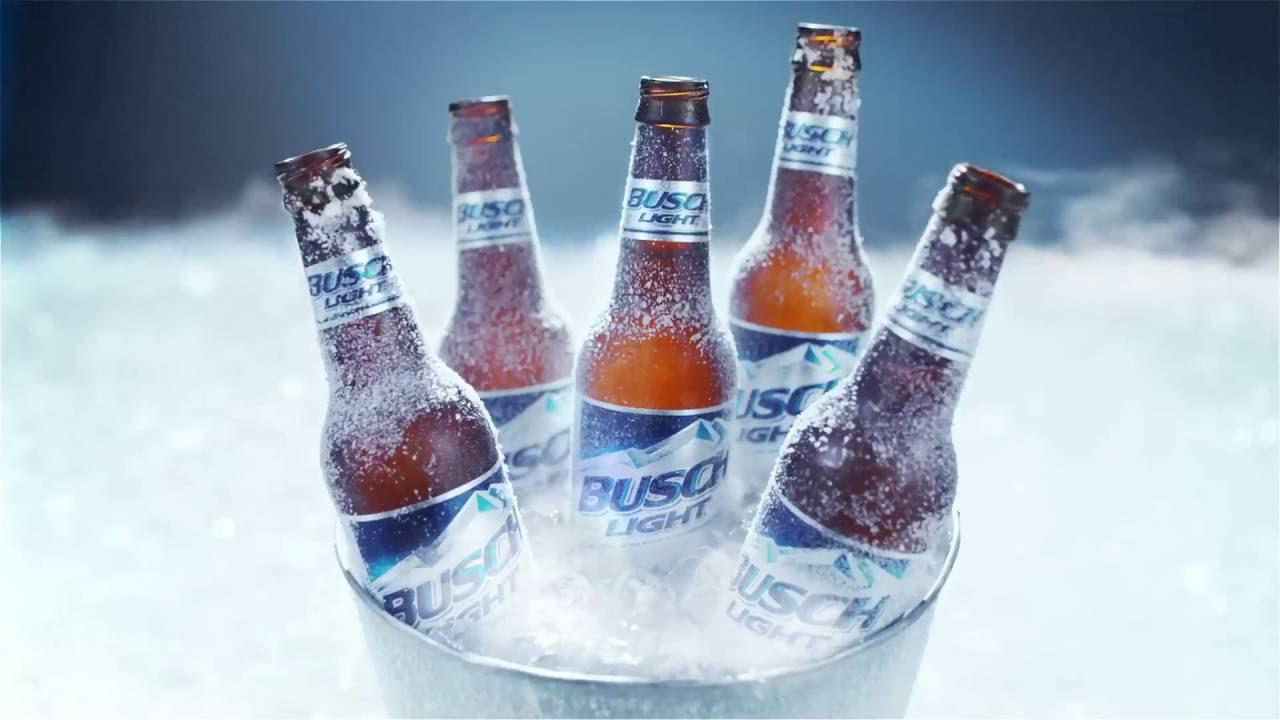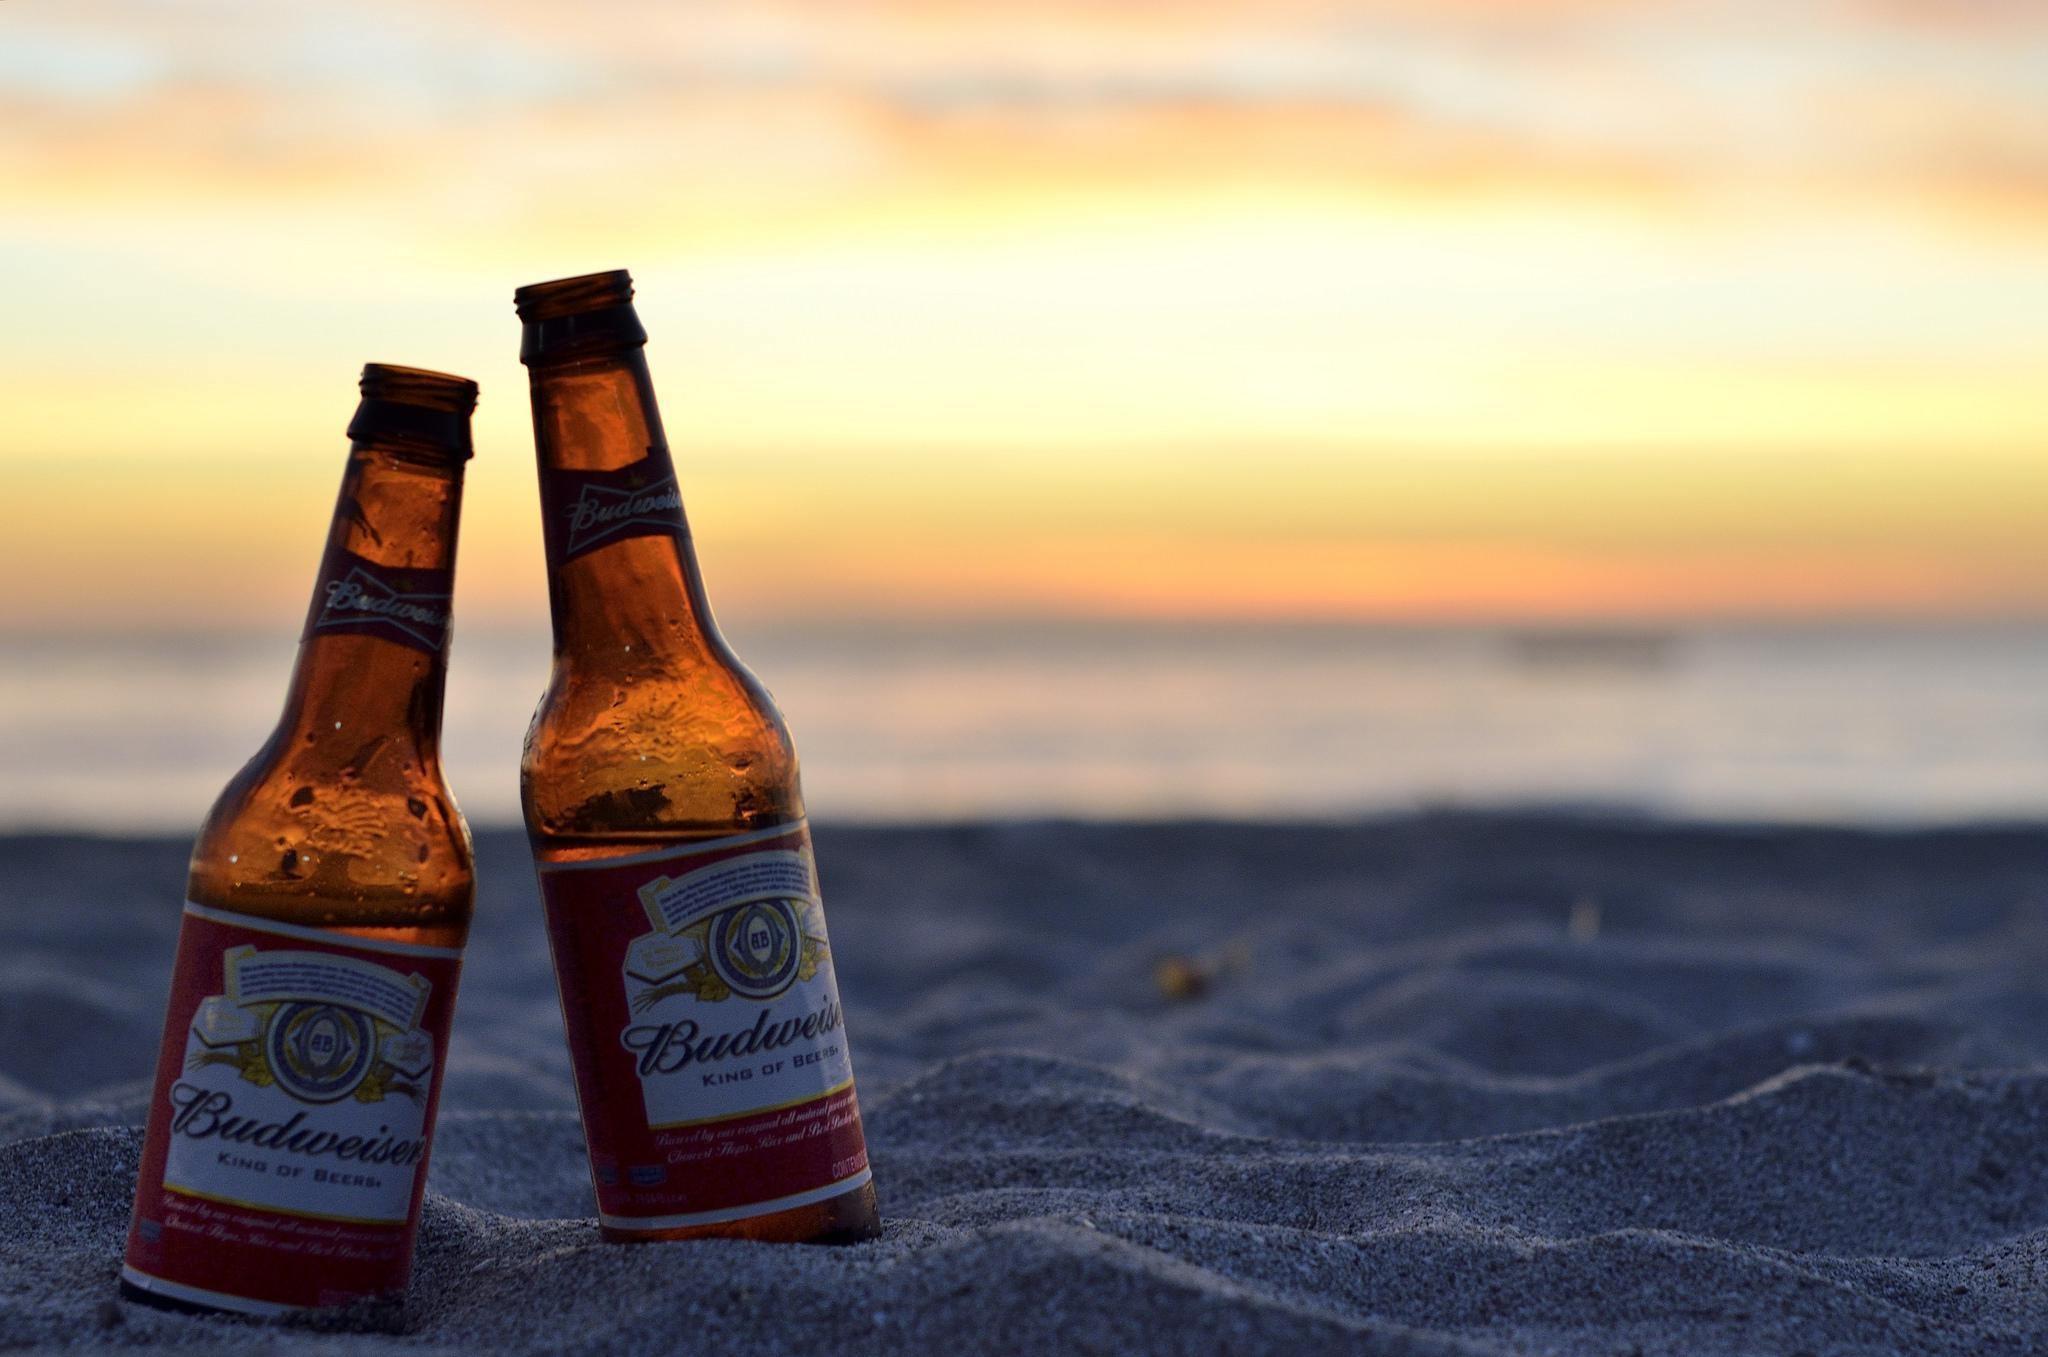The first image is the image on the left, the second image is the image on the right. Analyze the images presented: Is the assertion "At least one beer bottle is posed in front of a beach sunset, in one image." valid? Answer yes or no. Yes. The first image is the image on the left, the second image is the image on the right. For the images displayed, is the sentence "All beverage bottles have labels around both the body and neck of the bottle." factually correct? Answer yes or no. Yes. 